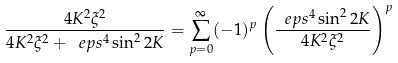Convert formula to latex. <formula><loc_0><loc_0><loc_500><loc_500>\frac { 4 K ^ { 2 } { \xi } ^ { 2 } } { 4 K ^ { 2 } { \xi } ^ { 2 } + \ e p s ^ { 4 } \sin ^ { 2 } 2 K } = \sum _ { p = 0 } ^ { \infty } ( - 1 ) ^ { p } \left ( \frac { \ e p s ^ { 4 } \sin ^ { 2 } 2 K } { 4 K ^ { 2 } { \xi } ^ { 2 } } \right ) ^ { p }</formula> 